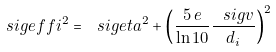<formula> <loc_0><loc_0><loc_500><loc_500>\ s i g e f f i ^ { 2 } = \ s i g e t a ^ { 2 } + \left ( \frac { 5 \, e } { \ln 1 0 } \frac { \ s i g v } { d _ { i } } \right ) ^ { 2 }</formula> 